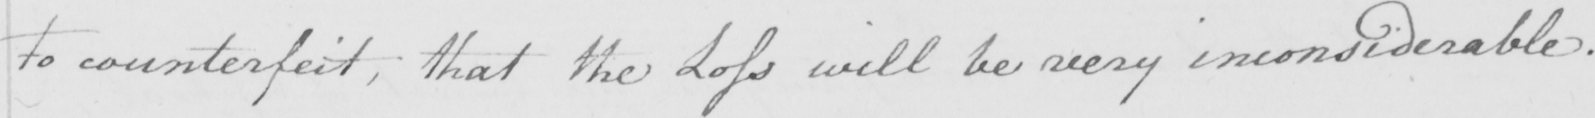Transcribe the text shown in this historical manuscript line. to counterfeit , that the Loss will be very inconsiderable . 